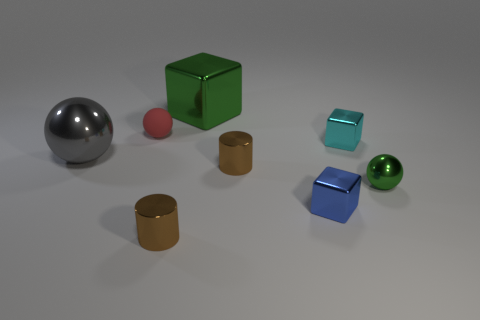Are there any other things that have the same material as the small red thing?
Your answer should be compact. No. Is there anything else that has the same size as the green shiny block?
Ensure brevity in your answer.  Yes. What is the size of the green metal thing that is to the right of the big thing on the right side of the gray metal thing?
Give a very brief answer. Small. There is a small metallic object behind the big gray ball; is its shape the same as the blue thing?
Make the answer very short. Yes. What material is the red thing that is the same shape as the big gray thing?
Provide a short and direct response. Rubber. What number of objects are either metal blocks that are in front of the large gray sphere or tiny cylinders that are in front of the blue thing?
Your answer should be very brief. 2. Do the large cube and the tiny sphere behind the gray shiny ball have the same color?
Your answer should be compact. No. What shape is the cyan thing that is the same material as the large green block?
Provide a succinct answer. Cube. How many matte balls are there?
Offer a terse response. 1. How many things are spheres to the left of the tiny red sphere or small blue shiny cubes?
Your response must be concise. 2. 